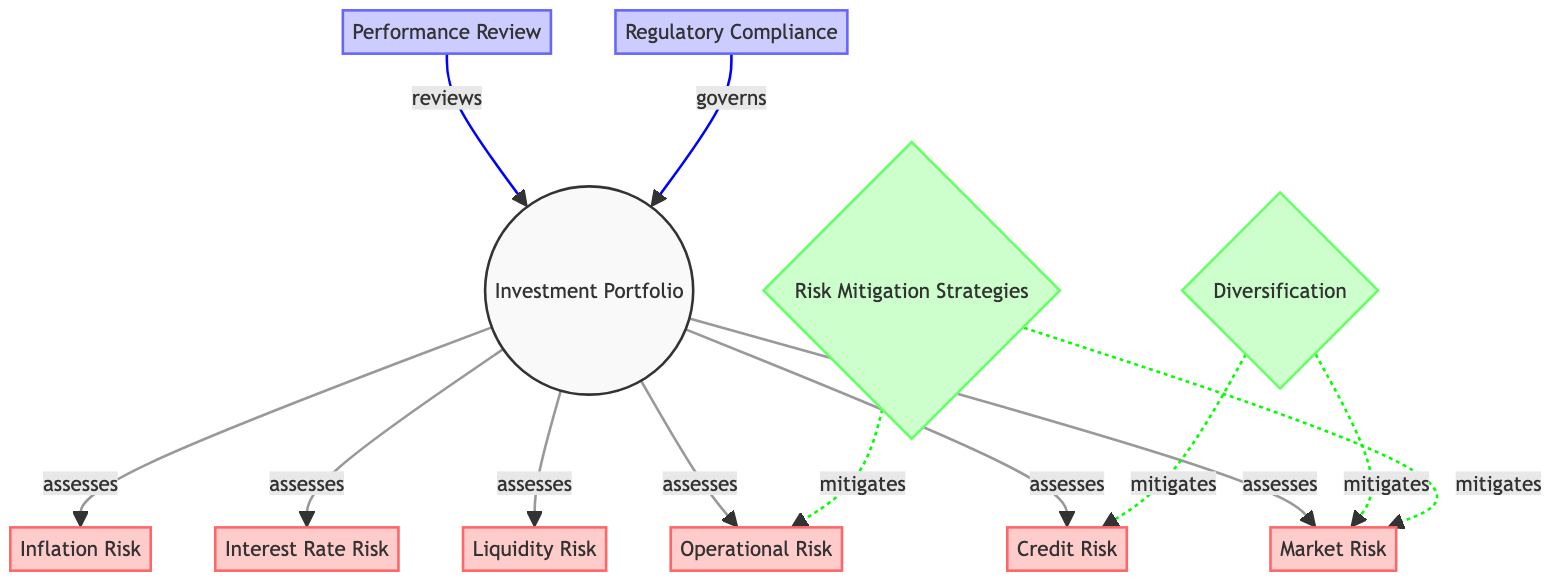What are the risks that the investment portfolio assesses? The investment portfolio node has directed edges to Market Risk, Credit Risk, Liquidity Risk, Operational Risk, Interest Rate Risk, and Inflation Risk, indicating that it assesses these risks.
Answer: Market Risk, Credit Risk, Liquidity Risk, Operational Risk, Interest Rate Risk, Inflation Risk How many risk types are shown in the diagram? The diagram includes six risk types: Market Risk, Credit Risk, Liquidity Risk, Operational Risk, Interest Rate Risk, and Inflation Risk. Counting these nodes gives us a total of six.
Answer: Six Which node mitigates both market risk and credit risk? The Diversification node has directed edges to both Market Risk and Credit Risk with a "mitigates" label, indicating that it mitigates these risks.
Answer: Diversification What is the relationship between performance review and portfolio? The arrow indicates that Performance Review reviews the Investment Portfolio, established through the "reviews" label on the edge connecting them.
Answer: Reviews Which two nodes connect to operational risk with a mitigating relationship? The arrows from Diversification and Risk Mitigation indicate that both nodes mitigate Operational Risk, clearly showing their relationship to this particular risk.
Answer: Diversification, Risk Mitigation What role does regulatory compliance play in relation to the investment portfolio? The diagram shows that Regulatory Compliance governs the Investment Portfolio, as indicated by the directed edge and the label "governs" connecting them.
Answer: Governs How many nodes represent strategies in this diagram? The diagram has two nodes labeled Diversification and Risk Mitigation Strategies, both categorized as strategies. Thus, the count of strategy nodes is two.
Answer: Two Which risks are mitigated by risk mitigation strategies? The risk mitigation strategies node has directed edges mitigating Market Risk and Operational Risk, noted by the corresponding labels.
Answer: Market Risk, Operational Risk 